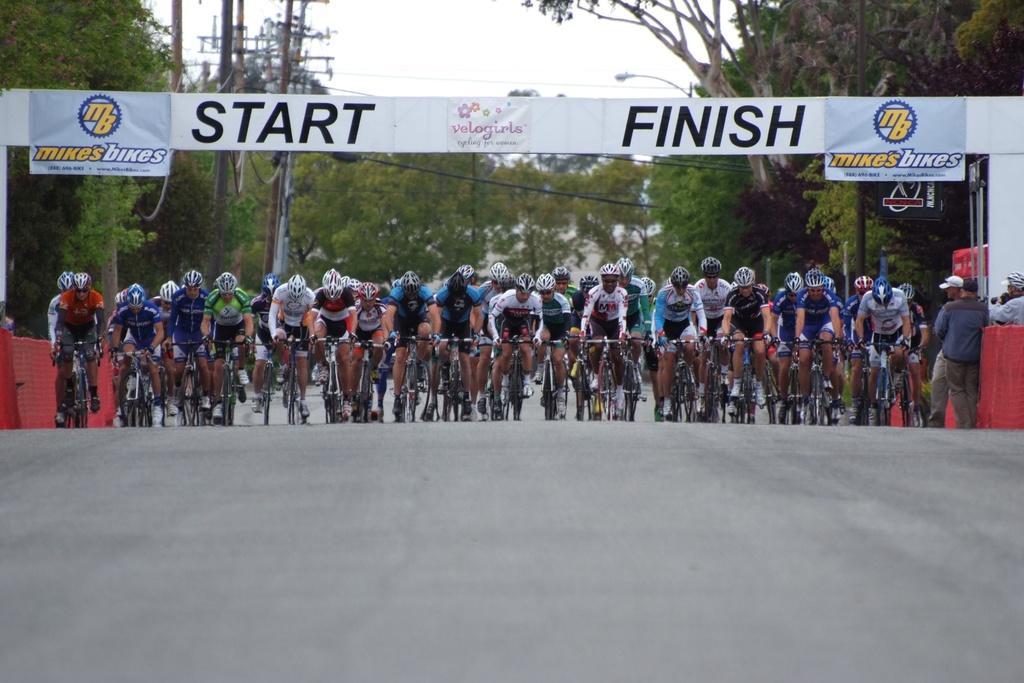Can you describe this image briefly? In this picture, in the middle, we can see group of people are riding a bicycle. On the right side, we can see few men are standing on the road. In the background, there are some hoardings, trees, electric pole, electric wires, street light. On the top, we can see a sky, at the bottom there is a road. 